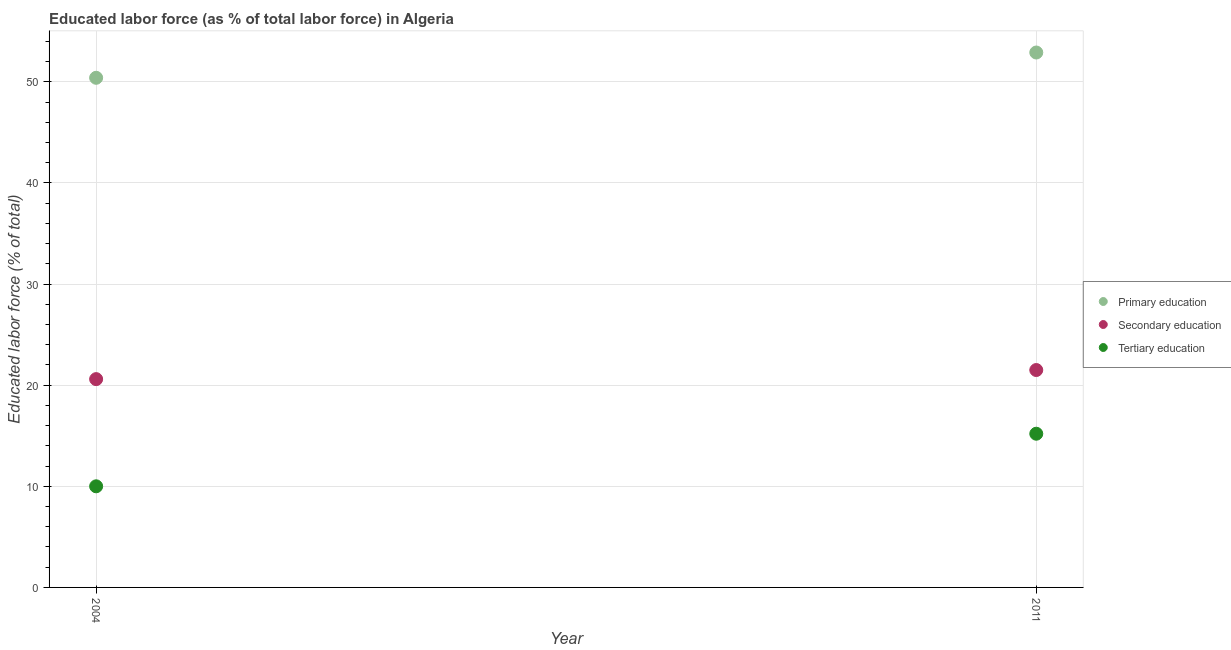Is the number of dotlines equal to the number of legend labels?
Your answer should be compact. Yes. What is the percentage of labor force who received tertiary education in 2011?
Your answer should be very brief. 15.2. Across all years, what is the maximum percentage of labor force who received tertiary education?
Offer a very short reply. 15.2. Across all years, what is the minimum percentage of labor force who received primary education?
Offer a very short reply. 50.4. In which year was the percentage of labor force who received tertiary education minimum?
Offer a terse response. 2004. What is the total percentage of labor force who received secondary education in the graph?
Your answer should be very brief. 42.1. What is the difference between the percentage of labor force who received secondary education in 2004 and that in 2011?
Your answer should be compact. -0.9. What is the difference between the percentage of labor force who received tertiary education in 2011 and the percentage of labor force who received secondary education in 2004?
Make the answer very short. -5.4. What is the average percentage of labor force who received tertiary education per year?
Offer a terse response. 12.6. In the year 2011, what is the difference between the percentage of labor force who received secondary education and percentage of labor force who received tertiary education?
Your response must be concise. 6.3. What is the ratio of the percentage of labor force who received primary education in 2004 to that in 2011?
Make the answer very short. 0.95. In how many years, is the percentage of labor force who received secondary education greater than the average percentage of labor force who received secondary education taken over all years?
Make the answer very short. 1. Is it the case that in every year, the sum of the percentage of labor force who received primary education and percentage of labor force who received secondary education is greater than the percentage of labor force who received tertiary education?
Your answer should be very brief. Yes. Is the percentage of labor force who received tertiary education strictly greater than the percentage of labor force who received secondary education over the years?
Make the answer very short. No. Is the percentage of labor force who received secondary education strictly less than the percentage of labor force who received tertiary education over the years?
Keep it short and to the point. No. How many dotlines are there?
Keep it short and to the point. 3. What is the difference between two consecutive major ticks on the Y-axis?
Your response must be concise. 10. Does the graph contain any zero values?
Provide a succinct answer. No. What is the title of the graph?
Your response must be concise. Educated labor force (as % of total labor force) in Algeria. What is the label or title of the X-axis?
Give a very brief answer. Year. What is the label or title of the Y-axis?
Make the answer very short. Educated labor force (% of total). What is the Educated labor force (% of total) of Primary education in 2004?
Give a very brief answer. 50.4. What is the Educated labor force (% of total) of Secondary education in 2004?
Your answer should be very brief. 20.6. What is the Educated labor force (% of total) in Tertiary education in 2004?
Offer a terse response. 10. What is the Educated labor force (% of total) of Primary education in 2011?
Ensure brevity in your answer.  52.9. What is the Educated labor force (% of total) in Secondary education in 2011?
Provide a succinct answer. 21.5. What is the Educated labor force (% of total) in Tertiary education in 2011?
Your answer should be compact. 15.2. Across all years, what is the maximum Educated labor force (% of total) of Primary education?
Your answer should be very brief. 52.9. Across all years, what is the maximum Educated labor force (% of total) in Secondary education?
Give a very brief answer. 21.5. Across all years, what is the maximum Educated labor force (% of total) in Tertiary education?
Offer a terse response. 15.2. Across all years, what is the minimum Educated labor force (% of total) in Primary education?
Your answer should be compact. 50.4. Across all years, what is the minimum Educated labor force (% of total) of Secondary education?
Provide a short and direct response. 20.6. Across all years, what is the minimum Educated labor force (% of total) of Tertiary education?
Provide a short and direct response. 10. What is the total Educated labor force (% of total) in Primary education in the graph?
Make the answer very short. 103.3. What is the total Educated labor force (% of total) of Secondary education in the graph?
Offer a very short reply. 42.1. What is the total Educated labor force (% of total) in Tertiary education in the graph?
Make the answer very short. 25.2. What is the difference between the Educated labor force (% of total) in Primary education in 2004 and the Educated labor force (% of total) in Secondary education in 2011?
Keep it short and to the point. 28.9. What is the difference between the Educated labor force (% of total) of Primary education in 2004 and the Educated labor force (% of total) of Tertiary education in 2011?
Provide a succinct answer. 35.2. What is the difference between the Educated labor force (% of total) in Secondary education in 2004 and the Educated labor force (% of total) in Tertiary education in 2011?
Your answer should be very brief. 5.4. What is the average Educated labor force (% of total) of Primary education per year?
Your answer should be very brief. 51.65. What is the average Educated labor force (% of total) of Secondary education per year?
Make the answer very short. 21.05. What is the average Educated labor force (% of total) of Tertiary education per year?
Offer a very short reply. 12.6. In the year 2004, what is the difference between the Educated labor force (% of total) of Primary education and Educated labor force (% of total) of Secondary education?
Provide a succinct answer. 29.8. In the year 2004, what is the difference between the Educated labor force (% of total) of Primary education and Educated labor force (% of total) of Tertiary education?
Provide a succinct answer. 40.4. In the year 2011, what is the difference between the Educated labor force (% of total) of Primary education and Educated labor force (% of total) of Secondary education?
Your response must be concise. 31.4. In the year 2011, what is the difference between the Educated labor force (% of total) of Primary education and Educated labor force (% of total) of Tertiary education?
Keep it short and to the point. 37.7. What is the ratio of the Educated labor force (% of total) in Primary education in 2004 to that in 2011?
Offer a terse response. 0.95. What is the ratio of the Educated labor force (% of total) of Secondary education in 2004 to that in 2011?
Your answer should be compact. 0.96. What is the ratio of the Educated labor force (% of total) of Tertiary education in 2004 to that in 2011?
Your response must be concise. 0.66. What is the difference between the highest and the lowest Educated labor force (% of total) of Secondary education?
Ensure brevity in your answer.  0.9. 